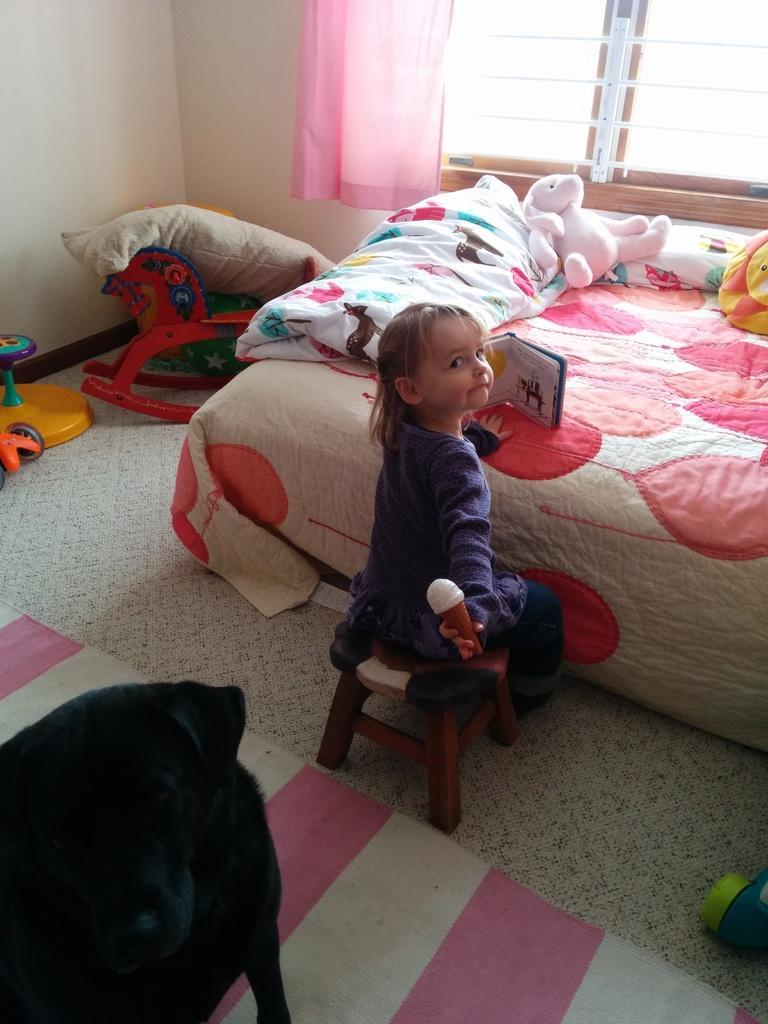Could you give a brief overview of what you see in this image? On the background we can see a wall, window and pink colour curtain. Here we can see a bed and on the bed we can see doll, blanket. Here we can see a girl sitting on a stool and she is holding ice cream in her hand. Here we can see a dog in black colour, floor carpet and floor. These are toys and a pillow. 